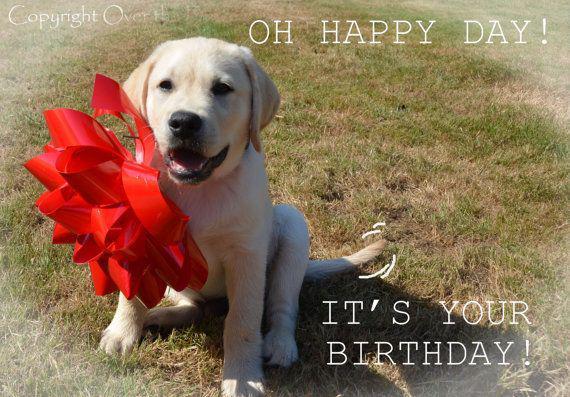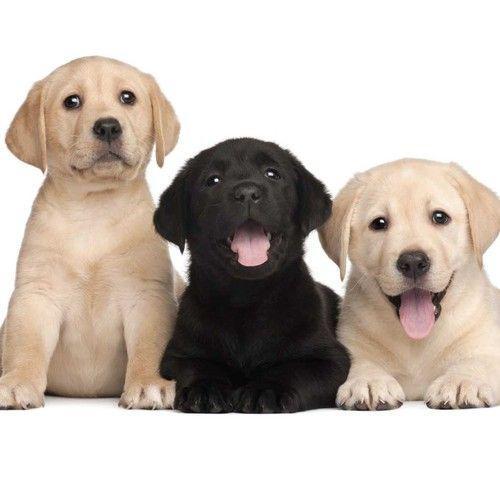The first image is the image on the left, the second image is the image on the right. For the images displayed, is the sentence "There are no more than five dogs" factually correct? Answer yes or no. Yes. 